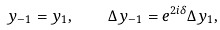<formula> <loc_0><loc_0><loc_500><loc_500>y _ { - 1 } = y _ { 1 } , \quad \Delta y _ { - 1 } = e ^ { 2 i \delta } \Delta y _ { 1 } ,</formula> 